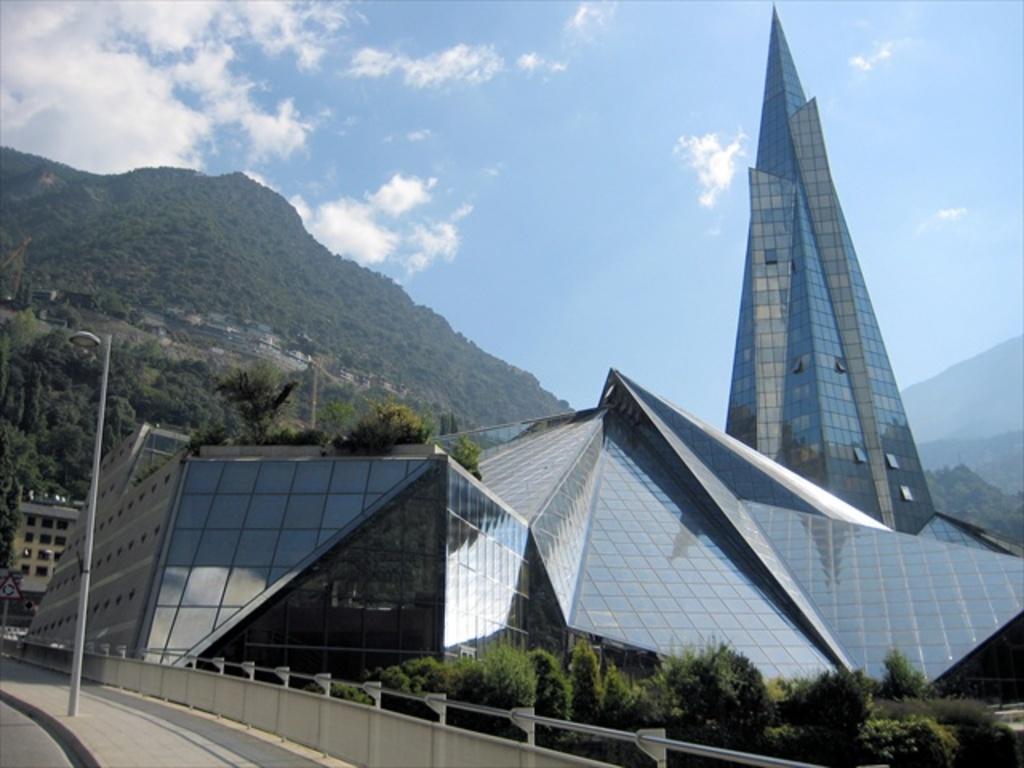Could you give a brief overview of what you see in this image? In this image, we can see a monument and in the background, there are buildings, trees, hills and we can see a board and a pole on the road. At the top, there are clouds in the sky. 